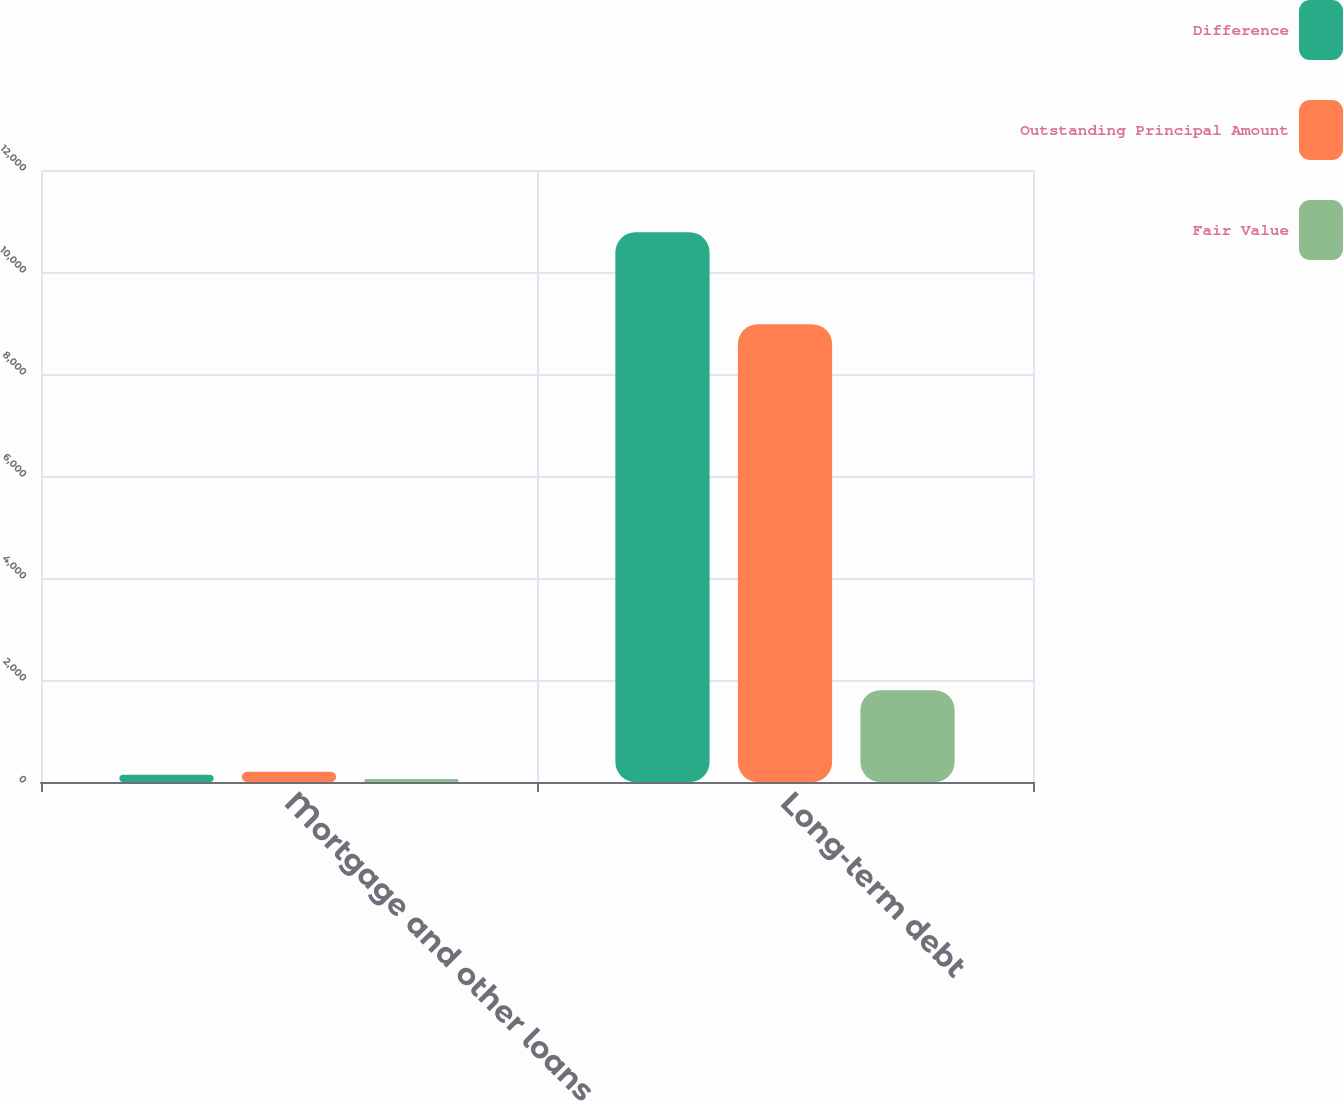Convert chart to OTSL. <chart><loc_0><loc_0><loc_500><loc_500><stacked_bar_chart><ecel><fcel>Mortgage and other loans<fcel>Long-term debt<nl><fcel>Difference<fcel>143<fcel>10778<nl><fcel>Outstanding Principal Amount<fcel>203<fcel>8977<nl><fcel>Fair Value<fcel>60<fcel>1801<nl></chart> 